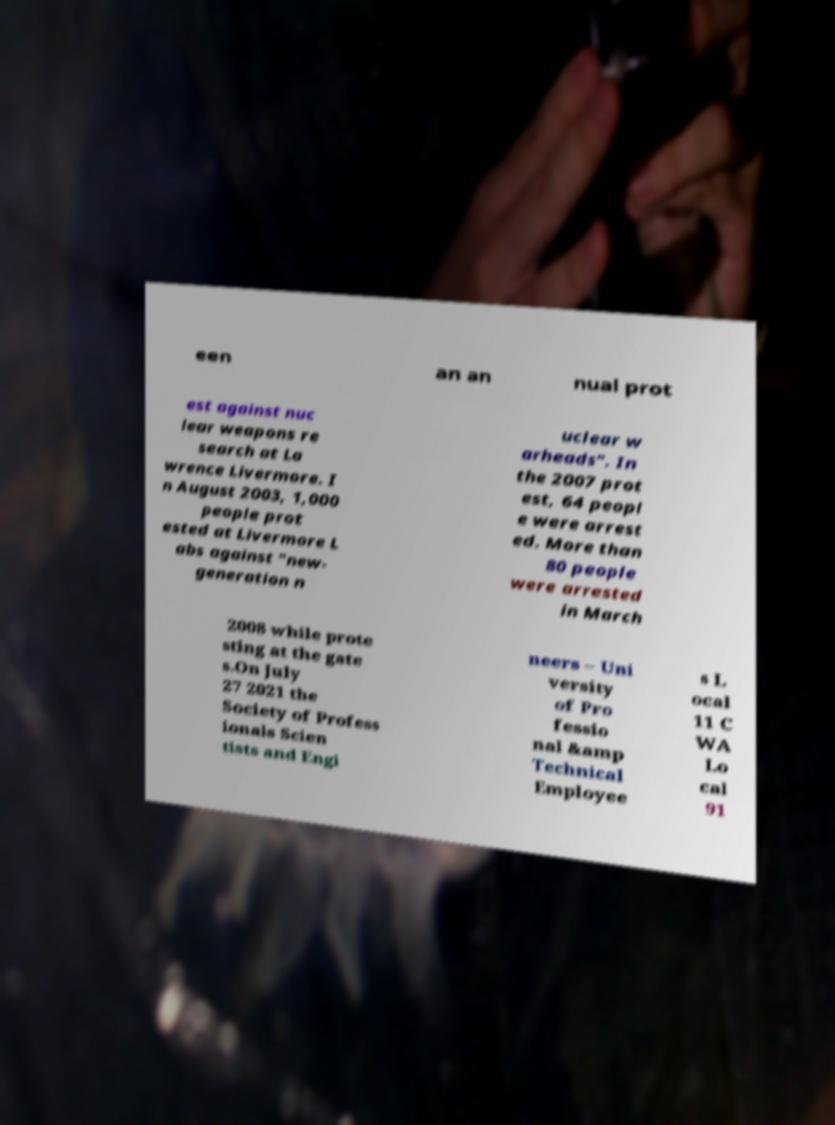Could you assist in decoding the text presented in this image and type it out clearly? een an an nual prot est against nuc lear weapons re search at La wrence Livermore. I n August 2003, 1,000 people prot ested at Livermore L abs against "new- generation n uclear w arheads". In the 2007 prot est, 64 peopl e were arrest ed. More than 80 people were arrested in March 2008 while prote sting at the gate s.On July 27 2021 the Society of Profess ionals Scien tists and Engi neers – Uni versity of Pro fessio nal &amp Technical Employee s L ocal 11 C WA Lo cal 91 